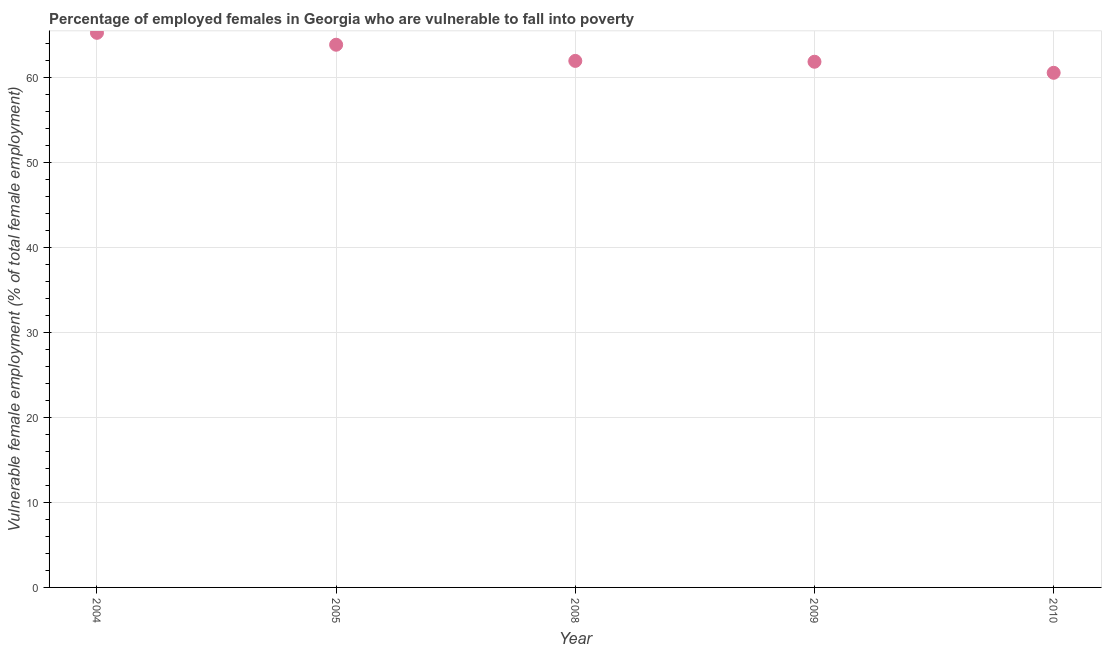What is the percentage of employed females who are vulnerable to fall into poverty in 2004?
Your answer should be compact. 65.2. Across all years, what is the maximum percentage of employed females who are vulnerable to fall into poverty?
Provide a short and direct response. 65.2. Across all years, what is the minimum percentage of employed females who are vulnerable to fall into poverty?
Provide a short and direct response. 60.5. In which year was the percentage of employed females who are vulnerable to fall into poverty minimum?
Ensure brevity in your answer.  2010. What is the sum of the percentage of employed females who are vulnerable to fall into poverty?
Ensure brevity in your answer.  313.2. What is the difference between the percentage of employed females who are vulnerable to fall into poverty in 2004 and 2010?
Keep it short and to the point. 4.7. What is the average percentage of employed females who are vulnerable to fall into poverty per year?
Provide a succinct answer. 62.64. What is the median percentage of employed females who are vulnerable to fall into poverty?
Ensure brevity in your answer.  61.9. Do a majority of the years between 2004 and 2008 (inclusive) have percentage of employed females who are vulnerable to fall into poverty greater than 48 %?
Keep it short and to the point. Yes. What is the ratio of the percentage of employed females who are vulnerable to fall into poverty in 2005 to that in 2009?
Give a very brief answer. 1.03. Is the difference between the percentage of employed females who are vulnerable to fall into poverty in 2004 and 2009 greater than the difference between any two years?
Offer a very short reply. No. What is the difference between the highest and the second highest percentage of employed females who are vulnerable to fall into poverty?
Keep it short and to the point. 1.4. Is the sum of the percentage of employed females who are vulnerable to fall into poverty in 2008 and 2010 greater than the maximum percentage of employed females who are vulnerable to fall into poverty across all years?
Ensure brevity in your answer.  Yes. What is the difference between the highest and the lowest percentage of employed females who are vulnerable to fall into poverty?
Make the answer very short. 4.7. Does the percentage of employed females who are vulnerable to fall into poverty monotonically increase over the years?
Keep it short and to the point. No. How many dotlines are there?
Offer a very short reply. 1. Does the graph contain grids?
Keep it short and to the point. Yes. What is the title of the graph?
Your response must be concise. Percentage of employed females in Georgia who are vulnerable to fall into poverty. What is the label or title of the Y-axis?
Provide a short and direct response. Vulnerable female employment (% of total female employment). What is the Vulnerable female employment (% of total female employment) in 2004?
Your answer should be compact. 65.2. What is the Vulnerable female employment (% of total female employment) in 2005?
Keep it short and to the point. 63.8. What is the Vulnerable female employment (% of total female employment) in 2008?
Your answer should be compact. 61.9. What is the Vulnerable female employment (% of total female employment) in 2009?
Make the answer very short. 61.8. What is the Vulnerable female employment (% of total female employment) in 2010?
Make the answer very short. 60.5. What is the difference between the Vulnerable female employment (% of total female employment) in 2004 and 2008?
Offer a very short reply. 3.3. What is the difference between the Vulnerable female employment (% of total female employment) in 2004 and 2009?
Provide a succinct answer. 3.4. What is the difference between the Vulnerable female employment (% of total female employment) in 2008 and 2009?
Provide a short and direct response. 0.1. What is the difference between the Vulnerable female employment (% of total female employment) in 2008 and 2010?
Provide a succinct answer. 1.4. What is the ratio of the Vulnerable female employment (% of total female employment) in 2004 to that in 2005?
Provide a succinct answer. 1.02. What is the ratio of the Vulnerable female employment (% of total female employment) in 2004 to that in 2008?
Provide a succinct answer. 1.05. What is the ratio of the Vulnerable female employment (% of total female employment) in 2004 to that in 2009?
Your answer should be very brief. 1.05. What is the ratio of the Vulnerable female employment (% of total female employment) in 2004 to that in 2010?
Make the answer very short. 1.08. What is the ratio of the Vulnerable female employment (% of total female employment) in 2005 to that in 2008?
Your answer should be very brief. 1.03. What is the ratio of the Vulnerable female employment (% of total female employment) in 2005 to that in 2009?
Keep it short and to the point. 1.03. What is the ratio of the Vulnerable female employment (% of total female employment) in 2005 to that in 2010?
Keep it short and to the point. 1.05. What is the ratio of the Vulnerable female employment (% of total female employment) in 2009 to that in 2010?
Give a very brief answer. 1.02. 